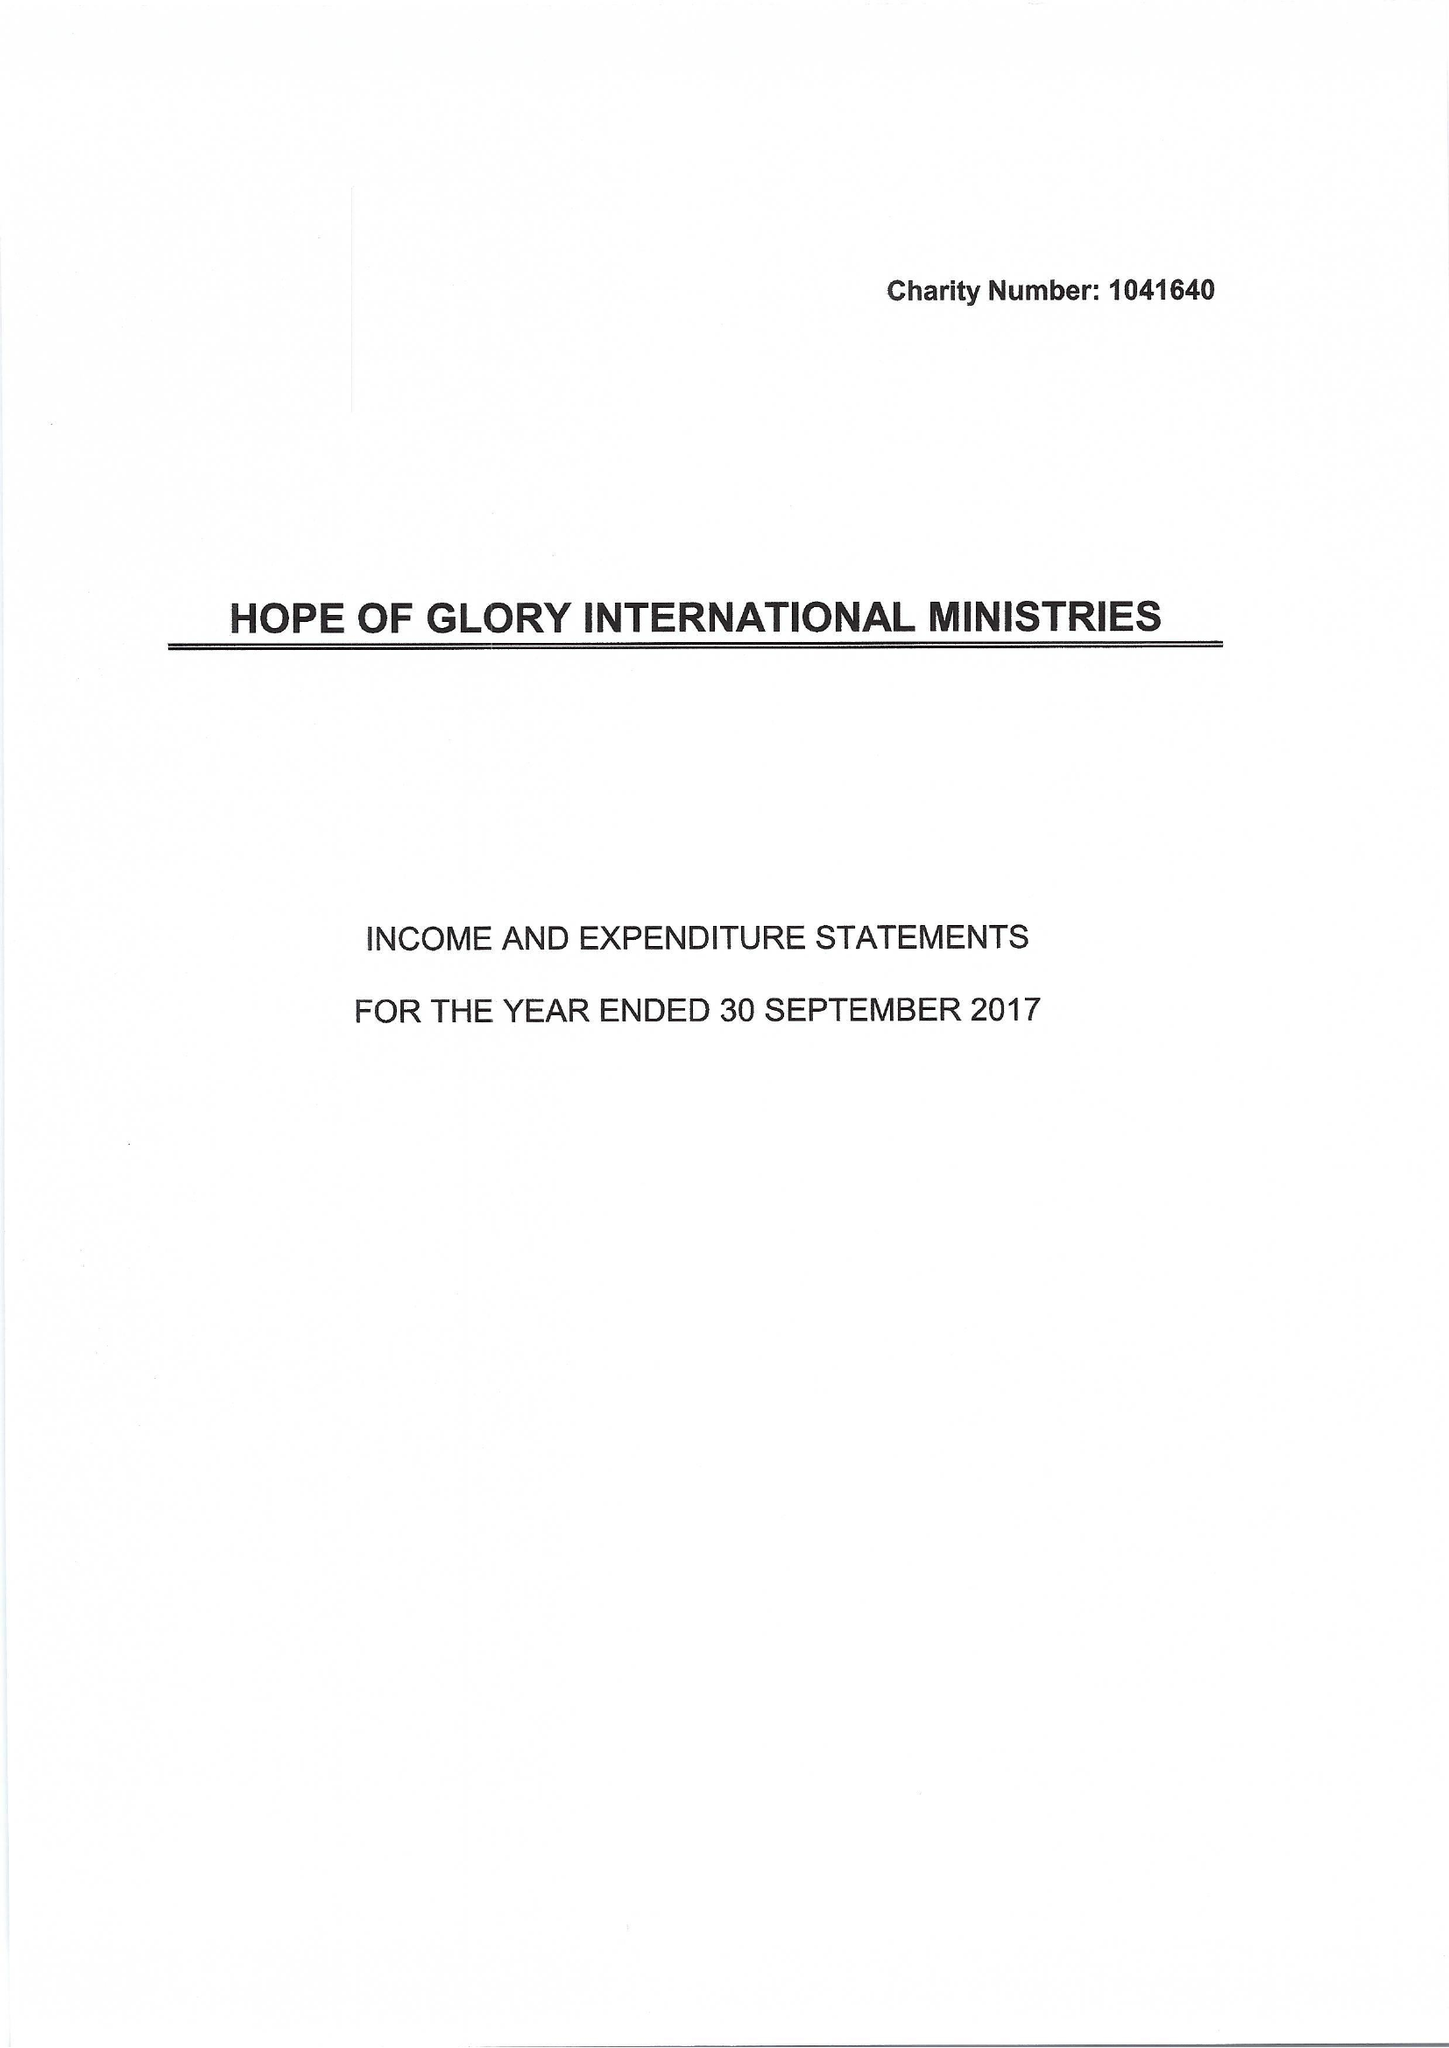What is the value for the charity_number?
Answer the question using a single word or phrase. 1041640 